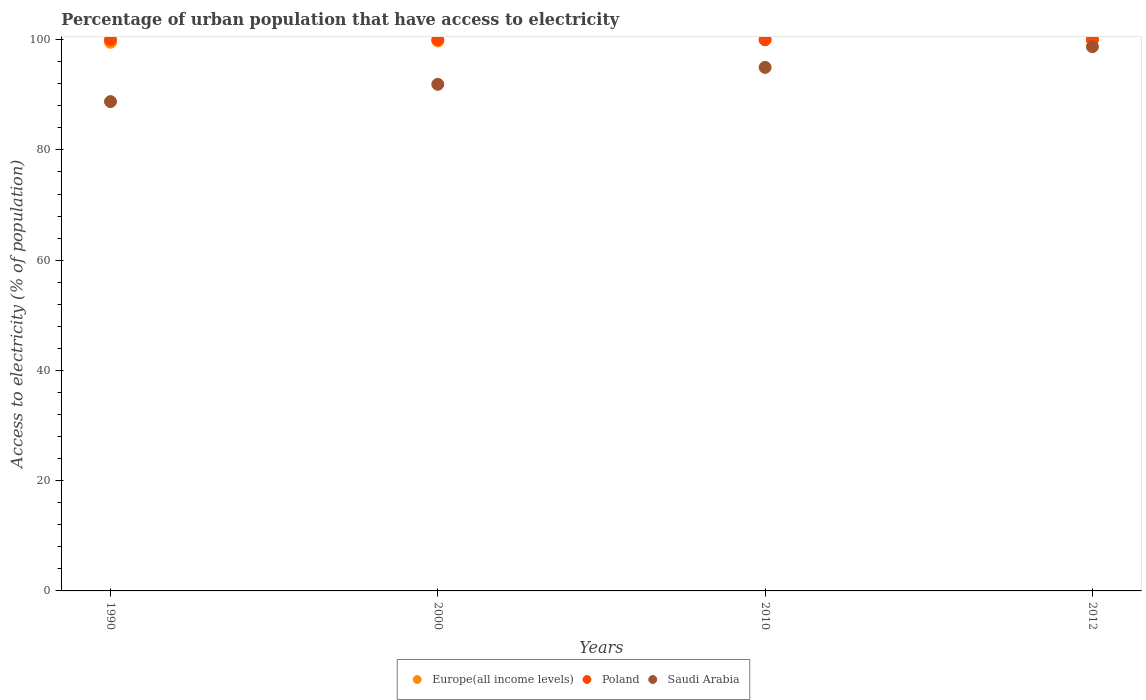Is the number of dotlines equal to the number of legend labels?
Your response must be concise. Yes. What is the percentage of urban population that have access to electricity in Poland in 2012?
Your response must be concise. 100. Across all years, what is the maximum percentage of urban population that have access to electricity in Saudi Arabia?
Offer a terse response. 98.73. Across all years, what is the minimum percentage of urban population that have access to electricity in Saudi Arabia?
Your answer should be very brief. 88.76. In which year was the percentage of urban population that have access to electricity in Poland maximum?
Your response must be concise. 1990. What is the total percentage of urban population that have access to electricity in Europe(all income levels) in the graph?
Make the answer very short. 399.29. What is the difference between the percentage of urban population that have access to electricity in Saudi Arabia in 2000 and that in 2010?
Provide a short and direct response. -3.07. What is the difference between the percentage of urban population that have access to electricity in Europe(all income levels) in 1990 and the percentage of urban population that have access to electricity in Poland in 2012?
Keep it short and to the point. -0.47. What is the average percentage of urban population that have access to electricity in Saudi Arabia per year?
Ensure brevity in your answer.  93.59. In the year 2000, what is the difference between the percentage of urban population that have access to electricity in Saudi Arabia and percentage of urban population that have access to electricity in Europe(all income levels)?
Provide a short and direct response. -7.87. What is the ratio of the percentage of urban population that have access to electricity in Saudi Arabia in 2010 to that in 2012?
Keep it short and to the point. 0.96. Is the difference between the percentage of urban population that have access to electricity in Saudi Arabia in 2000 and 2010 greater than the difference between the percentage of urban population that have access to electricity in Europe(all income levels) in 2000 and 2010?
Your answer should be very brief. No. What is the difference between the highest and the second highest percentage of urban population that have access to electricity in Europe(all income levels)?
Provide a succinct answer. 0.01. What is the difference between the highest and the lowest percentage of urban population that have access to electricity in Saudi Arabia?
Give a very brief answer. 9.96. In how many years, is the percentage of urban population that have access to electricity in Poland greater than the average percentage of urban population that have access to electricity in Poland taken over all years?
Your response must be concise. 0. Is it the case that in every year, the sum of the percentage of urban population that have access to electricity in Saudi Arabia and percentage of urban population that have access to electricity in Europe(all income levels)  is greater than the percentage of urban population that have access to electricity in Poland?
Offer a very short reply. Yes. Is the percentage of urban population that have access to electricity in Saudi Arabia strictly greater than the percentage of urban population that have access to electricity in Poland over the years?
Your response must be concise. No. How many years are there in the graph?
Provide a succinct answer. 4. What is the difference between two consecutive major ticks on the Y-axis?
Provide a succinct answer. 20. Are the values on the major ticks of Y-axis written in scientific E-notation?
Offer a terse response. No. Does the graph contain any zero values?
Provide a succinct answer. No. Does the graph contain grids?
Keep it short and to the point. No. Where does the legend appear in the graph?
Ensure brevity in your answer.  Bottom center. How are the legend labels stacked?
Ensure brevity in your answer.  Horizontal. What is the title of the graph?
Keep it short and to the point. Percentage of urban population that have access to electricity. Does "Bulgaria" appear as one of the legend labels in the graph?
Give a very brief answer. No. What is the label or title of the X-axis?
Ensure brevity in your answer.  Years. What is the label or title of the Y-axis?
Your answer should be very brief. Access to electricity (% of population). What is the Access to electricity (% of population) in Europe(all income levels) in 1990?
Offer a very short reply. 99.53. What is the Access to electricity (% of population) in Saudi Arabia in 1990?
Provide a short and direct response. 88.76. What is the Access to electricity (% of population) of Europe(all income levels) in 2000?
Your response must be concise. 99.77. What is the Access to electricity (% of population) in Saudi Arabia in 2000?
Your response must be concise. 91.9. What is the Access to electricity (% of population) in Europe(all income levels) in 2010?
Your response must be concise. 99.99. What is the Access to electricity (% of population) of Saudi Arabia in 2010?
Keep it short and to the point. 94.97. What is the Access to electricity (% of population) of Europe(all income levels) in 2012?
Make the answer very short. 100. What is the Access to electricity (% of population) of Poland in 2012?
Your response must be concise. 100. What is the Access to electricity (% of population) in Saudi Arabia in 2012?
Offer a very short reply. 98.73. Across all years, what is the maximum Access to electricity (% of population) in Europe(all income levels)?
Provide a succinct answer. 100. Across all years, what is the maximum Access to electricity (% of population) of Poland?
Offer a terse response. 100. Across all years, what is the maximum Access to electricity (% of population) of Saudi Arabia?
Provide a succinct answer. 98.73. Across all years, what is the minimum Access to electricity (% of population) in Europe(all income levels)?
Make the answer very short. 99.53. Across all years, what is the minimum Access to electricity (% of population) in Poland?
Give a very brief answer. 100. Across all years, what is the minimum Access to electricity (% of population) in Saudi Arabia?
Ensure brevity in your answer.  88.76. What is the total Access to electricity (% of population) in Europe(all income levels) in the graph?
Provide a succinct answer. 399.29. What is the total Access to electricity (% of population) of Saudi Arabia in the graph?
Offer a very short reply. 374.36. What is the difference between the Access to electricity (% of population) of Europe(all income levels) in 1990 and that in 2000?
Ensure brevity in your answer.  -0.24. What is the difference between the Access to electricity (% of population) of Saudi Arabia in 1990 and that in 2000?
Your response must be concise. -3.14. What is the difference between the Access to electricity (% of population) in Europe(all income levels) in 1990 and that in 2010?
Ensure brevity in your answer.  -0.45. What is the difference between the Access to electricity (% of population) of Saudi Arabia in 1990 and that in 2010?
Give a very brief answer. -6.21. What is the difference between the Access to electricity (% of population) in Europe(all income levels) in 1990 and that in 2012?
Provide a succinct answer. -0.46. What is the difference between the Access to electricity (% of population) of Saudi Arabia in 1990 and that in 2012?
Your answer should be compact. -9.96. What is the difference between the Access to electricity (% of population) of Europe(all income levels) in 2000 and that in 2010?
Make the answer very short. -0.22. What is the difference between the Access to electricity (% of population) of Poland in 2000 and that in 2010?
Ensure brevity in your answer.  0. What is the difference between the Access to electricity (% of population) of Saudi Arabia in 2000 and that in 2010?
Ensure brevity in your answer.  -3.07. What is the difference between the Access to electricity (% of population) of Europe(all income levels) in 2000 and that in 2012?
Your answer should be compact. -0.23. What is the difference between the Access to electricity (% of population) of Saudi Arabia in 2000 and that in 2012?
Your answer should be compact. -6.82. What is the difference between the Access to electricity (% of population) of Europe(all income levels) in 2010 and that in 2012?
Your answer should be very brief. -0.01. What is the difference between the Access to electricity (% of population) in Poland in 2010 and that in 2012?
Provide a succinct answer. 0. What is the difference between the Access to electricity (% of population) in Saudi Arabia in 2010 and that in 2012?
Provide a succinct answer. -3.75. What is the difference between the Access to electricity (% of population) of Europe(all income levels) in 1990 and the Access to electricity (% of population) of Poland in 2000?
Provide a short and direct response. -0.47. What is the difference between the Access to electricity (% of population) of Europe(all income levels) in 1990 and the Access to electricity (% of population) of Saudi Arabia in 2000?
Keep it short and to the point. 7.63. What is the difference between the Access to electricity (% of population) of Poland in 1990 and the Access to electricity (% of population) of Saudi Arabia in 2000?
Offer a very short reply. 8.1. What is the difference between the Access to electricity (% of population) of Europe(all income levels) in 1990 and the Access to electricity (% of population) of Poland in 2010?
Provide a succinct answer. -0.47. What is the difference between the Access to electricity (% of population) of Europe(all income levels) in 1990 and the Access to electricity (% of population) of Saudi Arabia in 2010?
Provide a succinct answer. 4.56. What is the difference between the Access to electricity (% of population) of Poland in 1990 and the Access to electricity (% of population) of Saudi Arabia in 2010?
Give a very brief answer. 5.03. What is the difference between the Access to electricity (% of population) in Europe(all income levels) in 1990 and the Access to electricity (% of population) in Poland in 2012?
Your answer should be very brief. -0.47. What is the difference between the Access to electricity (% of population) of Europe(all income levels) in 1990 and the Access to electricity (% of population) of Saudi Arabia in 2012?
Ensure brevity in your answer.  0.81. What is the difference between the Access to electricity (% of population) of Poland in 1990 and the Access to electricity (% of population) of Saudi Arabia in 2012?
Make the answer very short. 1.27. What is the difference between the Access to electricity (% of population) of Europe(all income levels) in 2000 and the Access to electricity (% of population) of Poland in 2010?
Your answer should be compact. -0.23. What is the difference between the Access to electricity (% of population) of Europe(all income levels) in 2000 and the Access to electricity (% of population) of Saudi Arabia in 2010?
Your answer should be very brief. 4.8. What is the difference between the Access to electricity (% of population) in Poland in 2000 and the Access to electricity (% of population) in Saudi Arabia in 2010?
Keep it short and to the point. 5.03. What is the difference between the Access to electricity (% of population) in Europe(all income levels) in 2000 and the Access to electricity (% of population) in Poland in 2012?
Keep it short and to the point. -0.23. What is the difference between the Access to electricity (% of population) of Europe(all income levels) in 2000 and the Access to electricity (% of population) of Saudi Arabia in 2012?
Provide a short and direct response. 1.04. What is the difference between the Access to electricity (% of population) in Poland in 2000 and the Access to electricity (% of population) in Saudi Arabia in 2012?
Offer a very short reply. 1.27. What is the difference between the Access to electricity (% of population) in Europe(all income levels) in 2010 and the Access to electricity (% of population) in Poland in 2012?
Provide a succinct answer. -0.01. What is the difference between the Access to electricity (% of population) in Europe(all income levels) in 2010 and the Access to electricity (% of population) in Saudi Arabia in 2012?
Ensure brevity in your answer.  1.26. What is the difference between the Access to electricity (% of population) of Poland in 2010 and the Access to electricity (% of population) of Saudi Arabia in 2012?
Ensure brevity in your answer.  1.27. What is the average Access to electricity (% of population) in Europe(all income levels) per year?
Your response must be concise. 99.82. What is the average Access to electricity (% of population) in Poland per year?
Offer a terse response. 100. What is the average Access to electricity (% of population) in Saudi Arabia per year?
Offer a very short reply. 93.59. In the year 1990, what is the difference between the Access to electricity (% of population) in Europe(all income levels) and Access to electricity (% of population) in Poland?
Offer a terse response. -0.47. In the year 1990, what is the difference between the Access to electricity (% of population) of Europe(all income levels) and Access to electricity (% of population) of Saudi Arabia?
Ensure brevity in your answer.  10.77. In the year 1990, what is the difference between the Access to electricity (% of population) of Poland and Access to electricity (% of population) of Saudi Arabia?
Keep it short and to the point. 11.24. In the year 2000, what is the difference between the Access to electricity (% of population) of Europe(all income levels) and Access to electricity (% of population) of Poland?
Provide a succinct answer. -0.23. In the year 2000, what is the difference between the Access to electricity (% of population) in Europe(all income levels) and Access to electricity (% of population) in Saudi Arabia?
Offer a terse response. 7.87. In the year 2000, what is the difference between the Access to electricity (% of population) in Poland and Access to electricity (% of population) in Saudi Arabia?
Your answer should be compact. 8.1. In the year 2010, what is the difference between the Access to electricity (% of population) of Europe(all income levels) and Access to electricity (% of population) of Poland?
Your answer should be very brief. -0.01. In the year 2010, what is the difference between the Access to electricity (% of population) in Europe(all income levels) and Access to electricity (% of population) in Saudi Arabia?
Your answer should be very brief. 5.01. In the year 2010, what is the difference between the Access to electricity (% of population) in Poland and Access to electricity (% of population) in Saudi Arabia?
Your response must be concise. 5.03. In the year 2012, what is the difference between the Access to electricity (% of population) in Europe(all income levels) and Access to electricity (% of population) in Poland?
Give a very brief answer. -0. In the year 2012, what is the difference between the Access to electricity (% of population) of Europe(all income levels) and Access to electricity (% of population) of Saudi Arabia?
Provide a short and direct response. 1.27. In the year 2012, what is the difference between the Access to electricity (% of population) of Poland and Access to electricity (% of population) of Saudi Arabia?
Make the answer very short. 1.27. What is the ratio of the Access to electricity (% of population) in Saudi Arabia in 1990 to that in 2000?
Make the answer very short. 0.97. What is the ratio of the Access to electricity (% of population) of Europe(all income levels) in 1990 to that in 2010?
Your answer should be compact. 1. What is the ratio of the Access to electricity (% of population) of Saudi Arabia in 1990 to that in 2010?
Your response must be concise. 0.93. What is the ratio of the Access to electricity (% of population) of Europe(all income levels) in 1990 to that in 2012?
Offer a very short reply. 1. What is the ratio of the Access to electricity (% of population) of Poland in 1990 to that in 2012?
Your answer should be compact. 1. What is the ratio of the Access to electricity (% of population) of Saudi Arabia in 1990 to that in 2012?
Your response must be concise. 0.9. What is the ratio of the Access to electricity (% of population) of Saudi Arabia in 2000 to that in 2010?
Offer a terse response. 0.97. What is the ratio of the Access to electricity (% of population) in Europe(all income levels) in 2000 to that in 2012?
Provide a succinct answer. 1. What is the ratio of the Access to electricity (% of population) of Poland in 2000 to that in 2012?
Your response must be concise. 1. What is the ratio of the Access to electricity (% of population) in Saudi Arabia in 2000 to that in 2012?
Keep it short and to the point. 0.93. What is the ratio of the Access to electricity (% of population) in Poland in 2010 to that in 2012?
Your answer should be very brief. 1. What is the difference between the highest and the second highest Access to electricity (% of population) of Europe(all income levels)?
Your response must be concise. 0.01. What is the difference between the highest and the second highest Access to electricity (% of population) of Saudi Arabia?
Give a very brief answer. 3.75. What is the difference between the highest and the lowest Access to electricity (% of population) in Europe(all income levels)?
Your response must be concise. 0.46. What is the difference between the highest and the lowest Access to electricity (% of population) in Poland?
Make the answer very short. 0. What is the difference between the highest and the lowest Access to electricity (% of population) in Saudi Arabia?
Ensure brevity in your answer.  9.96. 